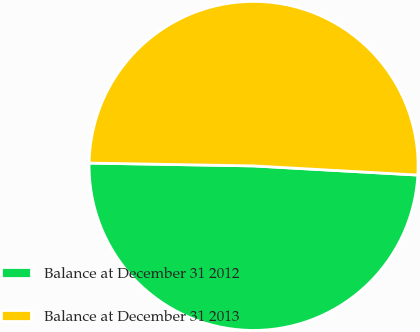<chart> <loc_0><loc_0><loc_500><loc_500><pie_chart><fcel>Balance at December 31 2012<fcel>Balance at December 31 2013<nl><fcel>49.39%<fcel>50.61%<nl></chart> 